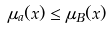Convert formula to latex. <formula><loc_0><loc_0><loc_500><loc_500>\mu _ { a } ( x ) \leq \mu _ { B } ( x )</formula> 